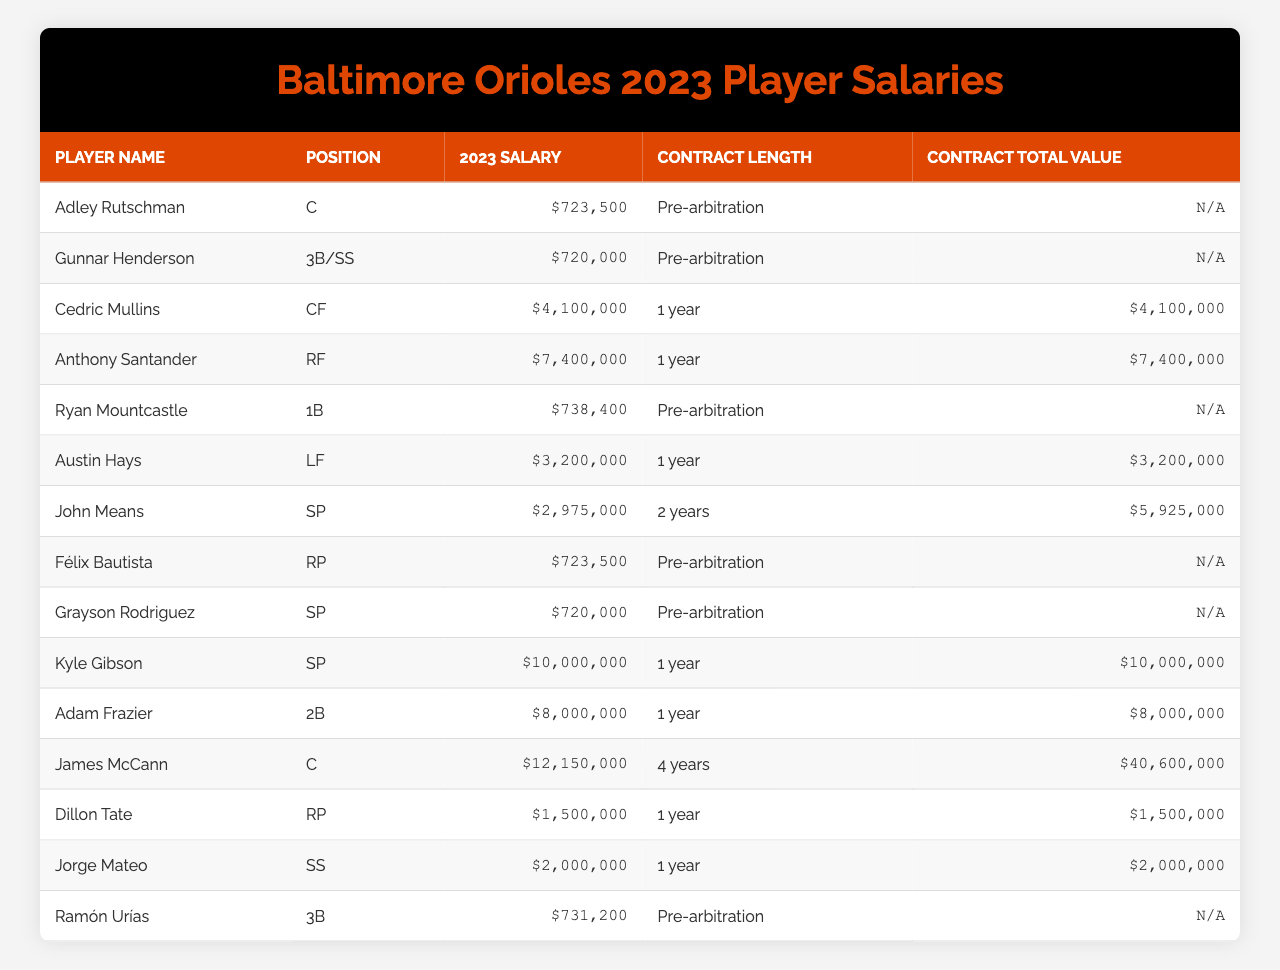What is Adley Rutschman's position? Refer to the table under the "Position" column corresponding to Adley Rutschman's name. He is listed as a 'C' (catcher).
Answer: C What is the salary of Cedric Mullins? Look at the "2023 Salary" column directly across from Cedric Mullins' name, which states his salary is $4,100,000.
Answer: $4,100,000 Which player has the highest contract total value? Check the "Contract Total Value" column for all players. James McCann has the highest total value of $40,600,000.
Answer: $40,600,000 How many players are in pre-arbitration? Count the entries in the "Contract Length" column that state "Pre-arbitration." There are 5 players in this category.
Answer: 5 What is the average salary of the players listed? Total all player salaries: ($723,500 + $720,000 + $4,100,000 + $7,400,000 + $738,400 + $3,200,000 + $2,975,000 + $723,500 + $720,000 + $10,000,000 + $8,000,000 + $1,500,000 + $2,000,000 + $731,200) = $43,413,100. Divide by the number of players (14) to find the average: $43,413,100 / 14 ≈ $3,086,650.
Answer: $3,086,650 Is Ryan Mountcastle signed for multiple years? Check the "Contract Length" column for Ryan Mountcastle. It states "Pre-arbitration," which indicates he is not under a multi-year contract.
Answer: No Which player has the lowest salary? Review the "2023 Salary" column, and it shows that both Adley Rutschman and Félix Bautista have the lowest salary of $723,500.
Answer: $723,500 Summing the salaries of players on a multi-year contract, what is the total? Identify players with "Contract Length" listed as multi-year in the table (John Means). His salary is $2,975,000 and contract value is $5,925,000. Therefore, the total salary for multi-year contracts is $2,975,000.
Answer: $2,975,000 How many players have a salary over $5,000,000? Look through the "2023 Salary" column and count the players whose salaries exceed $5,000,000. Three players have salaries over this amount (Cedric Mullins, Anthony Santander, and Kyle Gibson).
Answer: 3 Who among the players has the longest contract? Check the "Contract Length" column for each player. James McCann is signed for the longest duration of 4 years.
Answer: James McCann What percentage of the total salaries do the top 3 highest-paid players account for? Identify the top 3 salaries: Anthony Santander ($7,400,000), James McCann ($12,150,000), and Kyle Gibson ($10,000,000). Their total is $29,550,000. Calculate the full salary total ($43,413,100). The percentage is ($29,550,000 / $43,413,100) * 100 ≈ 68.06%.
Answer: 68.06% 